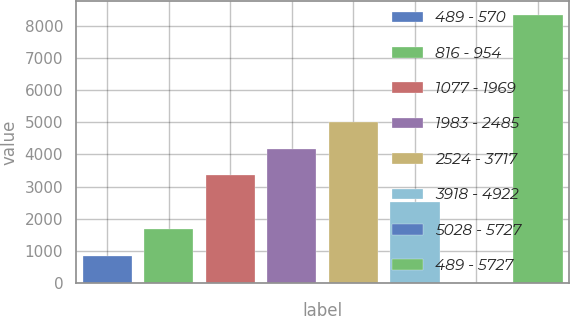Convert chart to OTSL. <chart><loc_0><loc_0><loc_500><loc_500><bar_chart><fcel>489 - 570<fcel>816 - 954<fcel>1077 - 1969<fcel>1983 - 2485<fcel>2524 - 3717<fcel>3918 - 4922<fcel>5028 - 5727<fcel>489 - 5727<nl><fcel>844.1<fcel>1678.2<fcel>3346.4<fcel>4180.5<fcel>5014.6<fcel>2512.3<fcel>10<fcel>8351<nl></chart> 